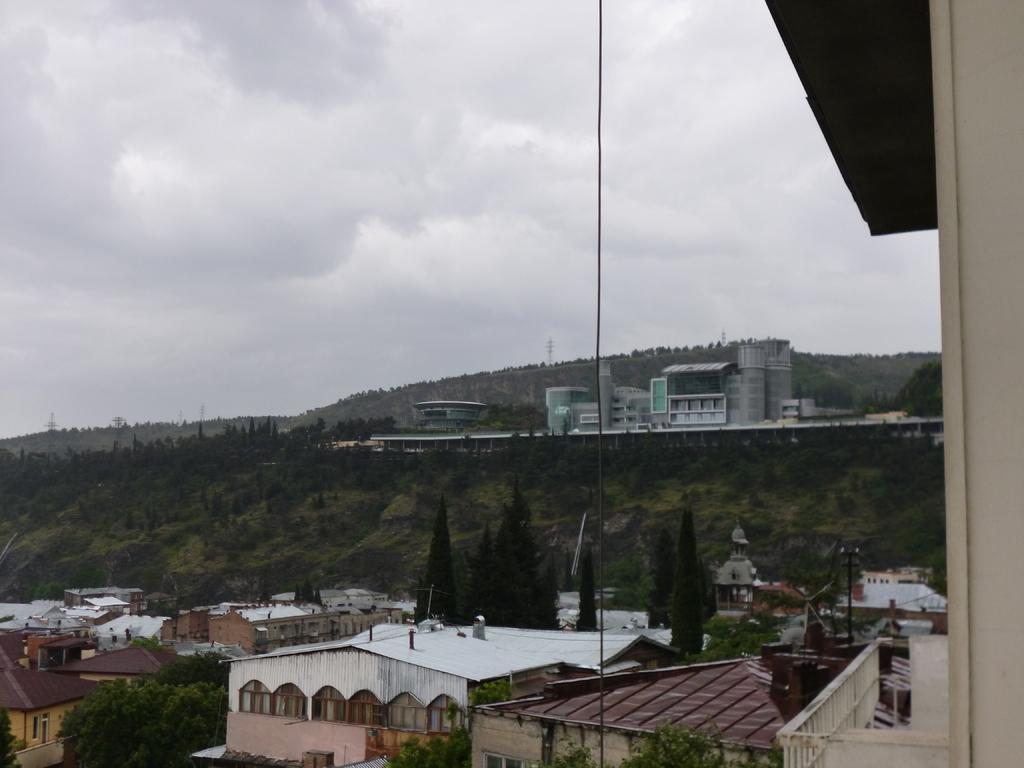Please provide a concise description of this image. This image is clicked outside. It consists of many buildings along with trees and plants. In the background, there is a mountain which is covered with plants. To the top, there are clouds in the sky. To the right, there is a building. 